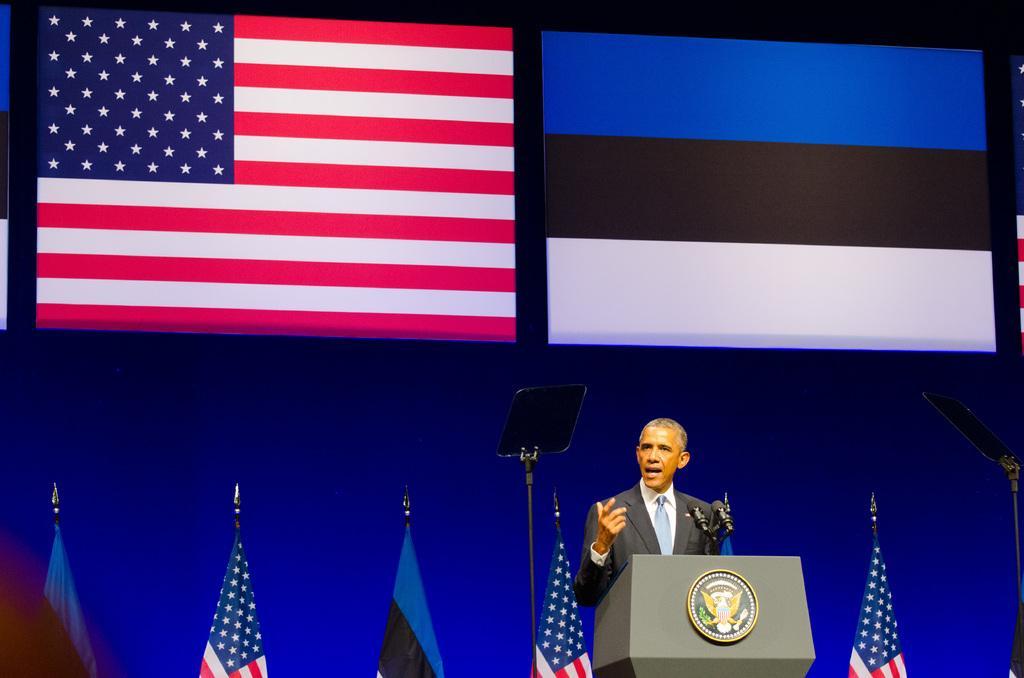Describe this image in one or two sentences. In this image we can see a person standing. In front of him there is a podium with emblem and mics. In the back there are flags with poles. Also there are stands. In the background it is blue. Also there are flags at the top. 